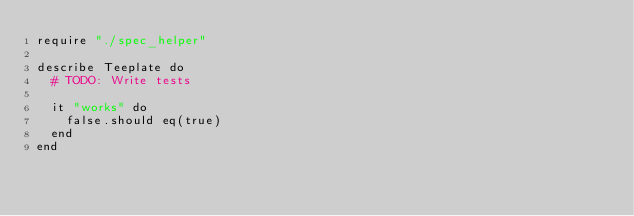<code> <loc_0><loc_0><loc_500><loc_500><_Crystal_>require "./spec_helper"

describe Teeplate do
  # TODO: Write tests

  it "works" do
    false.should eq(true)
  end
end
</code> 